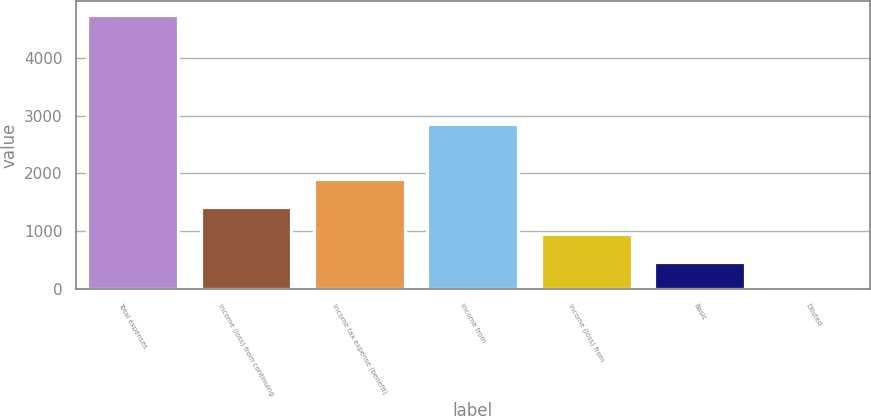Convert chart to OTSL. <chart><loc_0><loc_0><loc_500><loc_500><bar_chart><fcel>Total expenses<fcel>Income (loss) from continuing<fcel>Income tax expense (benefit)<fcel>Income from<fcel>Income (loss) from<fcel>Basic<fcel>Diluted<nl><fcel>4743<fcel>1423.97<fcel>1898.12<fcel>2846.42<fcel>949.82<fcel>475.67<fcel>1.52<nl></chart> 